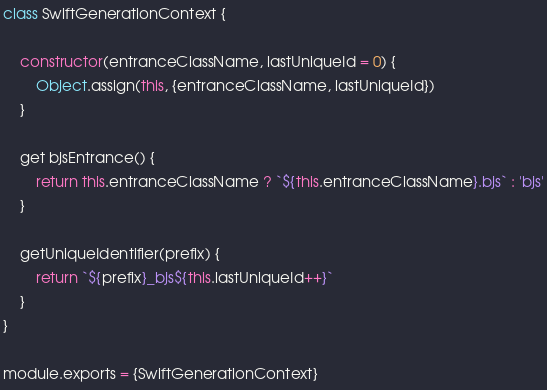<code> <loc_0><loc_0><loc_500><loc_500><_JavaScript_>class SwiftGenerationContext {

    constructor(entranceClassName, lastUniqueId = 0) {
        Object.assign(this, {entranceClassName, lastUniqueId})
    }

    get bjsEntrance() {
        return this.entranceClassName ? `${this.entranceClassName}.bjs` : 'bjs'
    }

    getUniqueIdentifier(prefix) {
        return `${prefix}_bjs${this.lastUniqueId++}`
    }
}

module.exports = {SwiftGenerationContext}</code> 